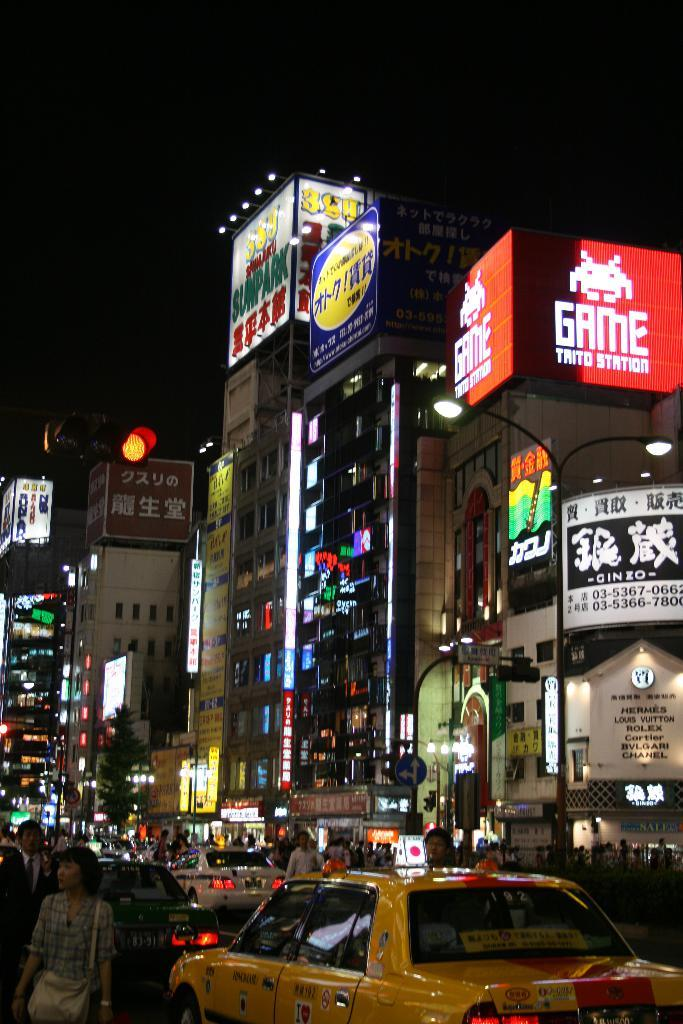Provide a one-sentence caption for the provided image. A busy city square at night shows people walking and congested traffic in a Japanese city filled with ads for products like Game Trito Station. 